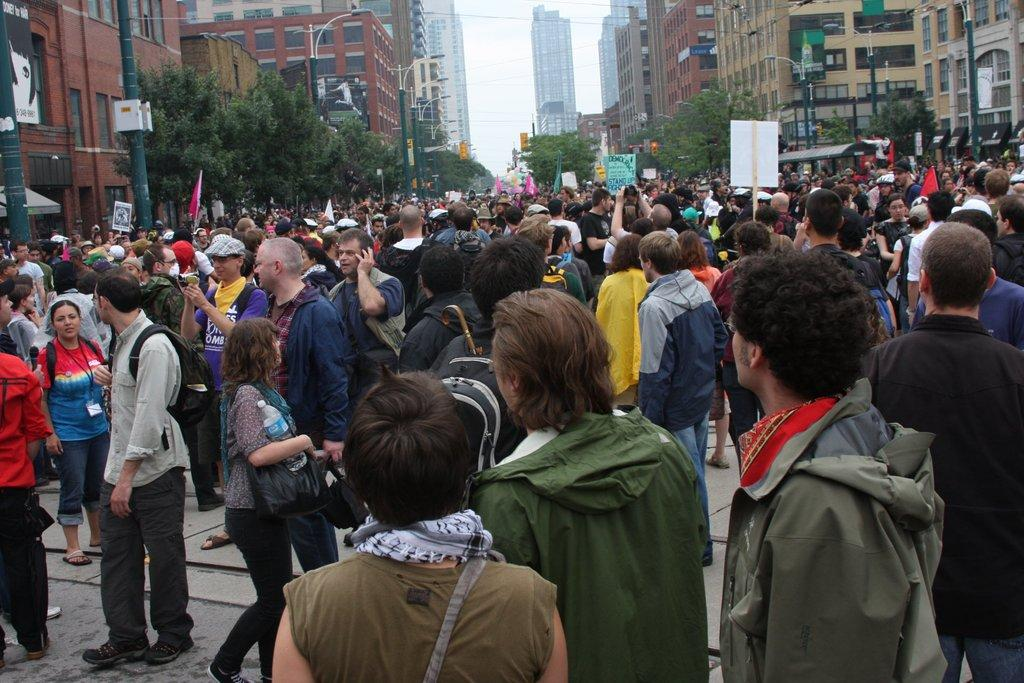What are the people in the image doing? The people in the image are standing and holding placards. What can be seen in the image besides the people? There are street lights, trees, buildings, and the sky visible in the image. Can you describe the lighting in the image? The street lights provide illumination in the image. What is visible in the background of the image? The sky is visible in the background of the image. What time of day is it in the image, considering the presence of the pencil? There is no pencil present in the image, so it cannot be used to determine the time of day. 